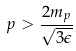Convert formula to latex. <formula><loc_0><loc_0><loc_500><loc_500>p > \frac { 2 m _ { p } } { \sqrt { 3 \epsilon } }</formula> 